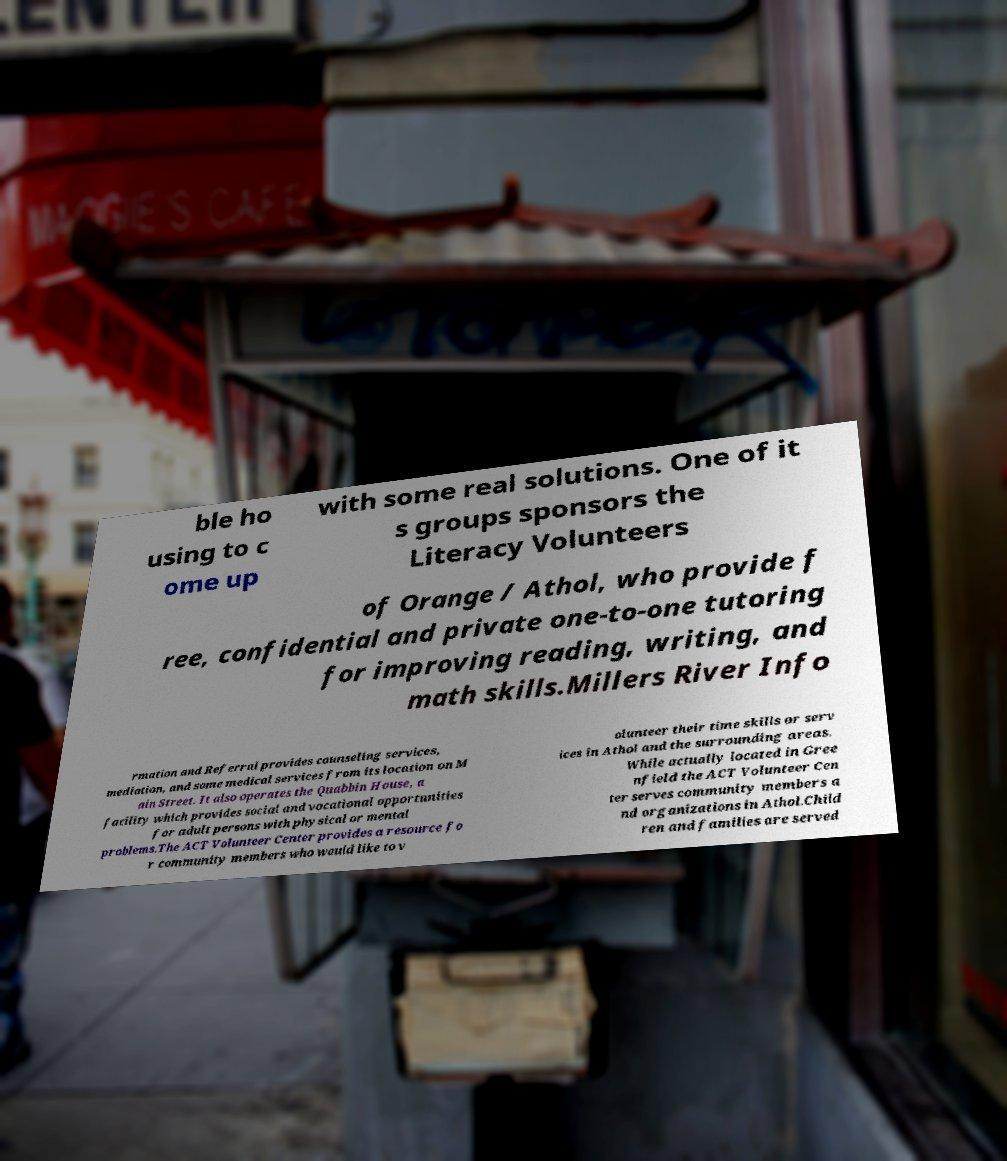Could you extract and type out the text from this image? ble ho using to c ome up with some real solutions. One of it s groups sponsors the Literacy Volunteers of Orange / Athol, who provide f ree, confidential and private one-to-one tutoring for improving reading, writing, and math skills.Millers River Info rmation and Referral provides counseling services, mediation, and some medical services from its location on M ain Street. It also operates the Quabbin House, a facility which provides social and vocational opportunities for adult persons with physical or mental problems.The ACT Volunteer Center provides a resource fo r community members who would like to v olunteer their time skills or serv ices in Athol and the surrounding areas. While actually located in Gree nfield the ACT Volunteer Cen ter serves community members a nd organizations in Athol.Child ren and families are served 